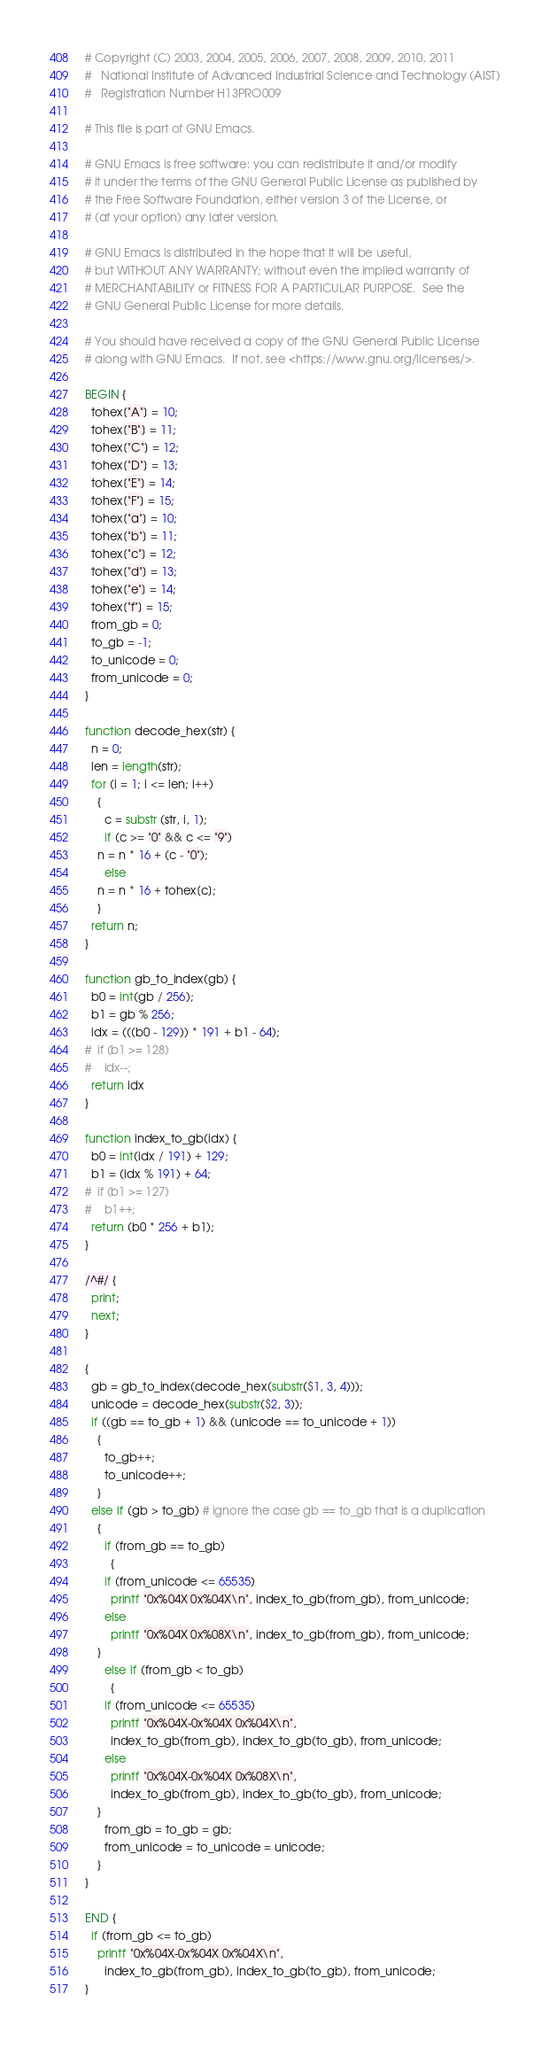<code> <loc_0><loc_0><loc_500><loc_500><_Awk_># Copyright (C) 2003, 2004, 2005, 2006, 2007, 2008, 2009, 2010, 2011
#   National Institute of Advanced Industrial Science and Technology (AIST)
#   Registration Number H13PRO009

# This file is part of GNU Emacs.

# GNU Emacs is free software: you can redistribute it and/or modify
# it under the terms of the GNU General Public License as published by
# the Free Software Foundation, either version 3 of the License, or
# (at your option) any later version.

# GNU Emacs is distributed in the hope that it will be useful,
# but WITHOUT ANY WARRANTY; without even the implied warranty of
# MERCHANTABILITY or FITNESS FOR A PARTICULAR PURPOSE.  See the
# GNU General Public License for more details.

# You should have received a copy of the GNU General Public License
# along with GNU Emacs.  If not, see <https://www.gnu.org/licenses/>.

BEGIN {
  tohex["A"] = 10;
  tohex["B"] = 11;
  tohex["C"] = 12;
  tohex["D"] = 13;
  tohex["E"] = 14;
  tohex["F"] = 15;
  tohex["a"] = 10;
  tohex["b"] = 11;
  tohex["c"] = 12;
  tohex["d"] = 13;
  tohex["e"] = 14;
  tohex["f"] = 15;
  from_gb = 0;
  to_gb = -1;
  to_unicode = 0;
  from_unicode = 0;
}

function decode_hex(str) {
  n = 0;
  len = length(str);
  for (i = 1; i <= len; i++)
    {
      c = substr (str, i, 1);
      if (c >= "0" && c <= "9")
	n = n * 16 + (c - "0");
      else
	n = n * 16 + tohex[c];
    }
  return n;
}

function gb_to_index(gb) {
  b0 = int(gb / 256);
  b1 = gb % 256;
  idx = (((b0 - 129)) * 191 + b1 - 64);
#  if (b1 >= 128)
#    idx--;
  return idx
}

function index_to_gb(idx) {
  b0 = int(idx / 191) + 129;
  b1 = (idx % 191) + 64;
#  if (b1 >= 127)
#    b1++;
  return (b0 * 256 + b1);
}

/^#/ {
  print;
  next;
}

{
  gb = gb_to_index(decode_hex(substr($1, 3, 4)));
  unicode = decode_hex(substr($2, 3));
  if ((gb == to_gb + 1) && (unicode == to_unicode + 1))
    {
      to_gb++;
      to_unicode++;
    }
  else if (gb > to_gb) # ignore the case gb == to_gb that is a duplication
    {
      if (from_gb == to_gb)
        {
	  if (from_unicode <= 65535)
	    printf "0x%04X 0x%04X\n", index_to_gb(from_gb), from_unicode;
	  else
	    printf "0x%04X 0x%08X\n", index_to_gb(from_gb), from_unicode;
	}
      else if (from_gb < to_gb)
        {
	  if (from_unicode <= 65535)
	    printf "0x%04X-0x%04X 0x%04X\n",
		index_to_gb(from_gb), index_to_gb(to_gb), from_unicode;
	  else
	    printf "0x%04X-0x%04X 0x%08X\n",
		index_to_gb(from_gb), index_to_gb(to_gb), from_unicode;
	}
      from_gb = to_gb = gb;
      from_unicode = to_unicode = unicode;
    }
}

END {
  if (from_gb <= to_gb)
    printf "0x%04X-0x%04X 0x%04X\n",
      index_to_gb(from_gb), index_to_gb(to_gb), from_unicode;
}
</code> 